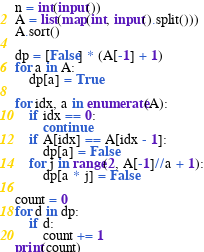<code> <loc_0><loc_0><loc_500><loc_500><_Python_>n = int(input())
A = list(map(int, input().split()))
A.sort()

dp = [False] * (A[-1] + 1)
for a in A:
    dp[a] = True

for idx, a in enumerate(A):
    if idx == 0:
        continue
    if A[idx] == A[idx - 1]:
        dp[a] = False
    for j in range(2, A[-1]//a + 1):
        dp[a * j] = False

count = 0
for d in dp:
    if d:
        count += 1
print(count)
</code> 